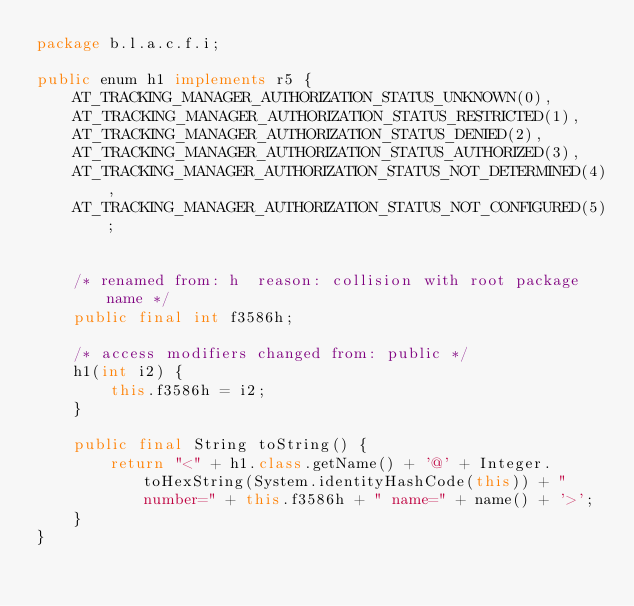Convert code to text. <code><loc_0><loc_0><loc_500><loc_500><_Java_>package b.l.a.c.f.i;

public enum h1 implements r5 {
    AT_TRACKING_MANAGER_AUTHORIZATION_STATUS_UNKNOWN(0),
    AT_TRACKING_MANAGER_AUTHORIZATION_STATUS_RESTRICTED(1),
    AT_TRACKING_MANAGER_AUTHORIZATION_STATUS_DENIED(2),
    AT_TRACKING_MANAGER_AUTHORIZATION_STATUS_AUTHORIZED(3),
    AT_TRACKING_MANAGER_AUTHORIZATION_STATUS_NOT_DETERMINED(4),
    AT_TRACKING_MANAGER_AUTHORIZATION_STATUS_NOT_CONFIGURED(5);
    

    /* renamed from: h  reason: collision with root package name */
    public final int f3586h;

    /* access modifiers changed from: public */
    h1(int i2) {
        this.f3586h = i2;
    }

    public final String toString() {
        return "<" + h1.class.getName() + '@' + Integer.toHexString(System.identityHashCode(this)) + " number=" + this.f3586h + " name=" + name() + '>';
    }
}
</code> 